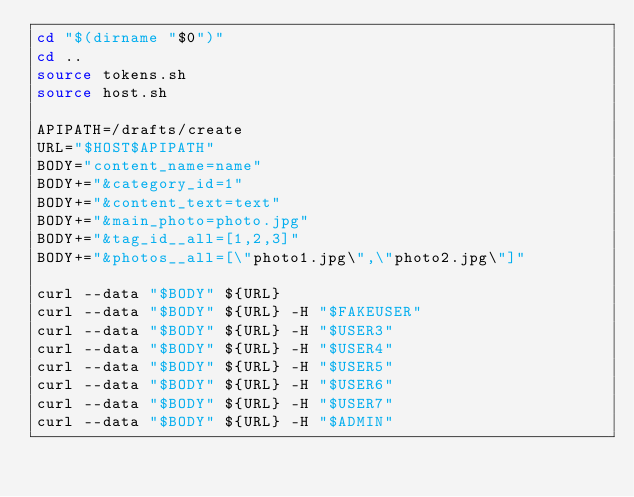Convert code to text. <code><loc_0><loc_0><loc_500><loc_500><_Bash_>cd "$(dirname "$0")"
cd ..
source tokens.sh
source host.sh

APIPATH=/drafts/create
URL="$HOST$APIPATH"
BODY="content_name=name"
BODY+="&category_id=1"
BODY+="&content_text=text"
BODY+="&main_photo=photo.jpg"
BODY+="&tag_id__all=[1,2,3]"
BODY+="&photos__all=[\"photo1.jpg\",\"photo2.jpg\"]"

curl --data "$BODY" ${URL}
curl --data "$BODY" ${URL} -H "$FAKEUSER"
curl --data "$BODY" ${URL} -H "$USER3"
curl --data "$BODY" ${URL} -H "$USER4"
curl --data "$BODY" ${URL} -H "$USER5"
curl --data "$BODY" ${URL} -H "$USER6"
curl --data "$BODY" ${URL} -H "$USER7"
curl --data "$BODY" ${URL} -H "$ADMIN"</code> 